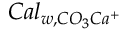<formula> <loc_0><loc_0><loc_500><loc_500>C a l _ { w , C O _ { 3 } C a ^ { + } }</formula> 